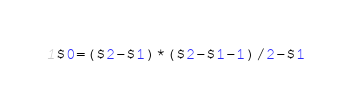<code> <loc_0><loc_0><loc_500><loc_500><_Awk_>$0=($2-$1)*($2-$1-1)/2-$1</code> 